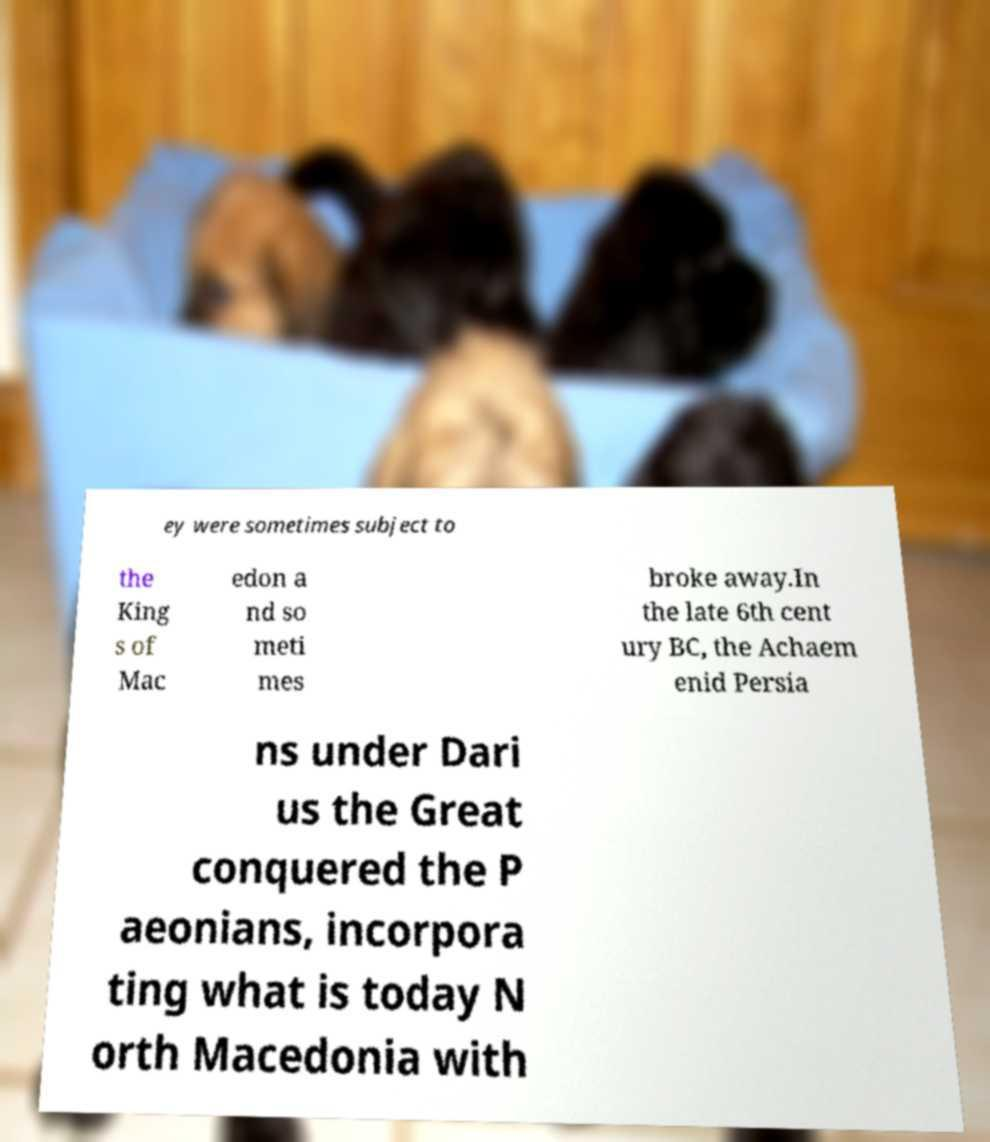Can you accurately transcribe the text from the provided image for me? ey were sometimes subject to the King s of Mac edon a nd so meti mes broke away.In the late 6th cent ury BC, the Achaem enid Persia ns under Dari us the Great conquered the P aeonians, incorpora ting what is today N orth Macedonia with 